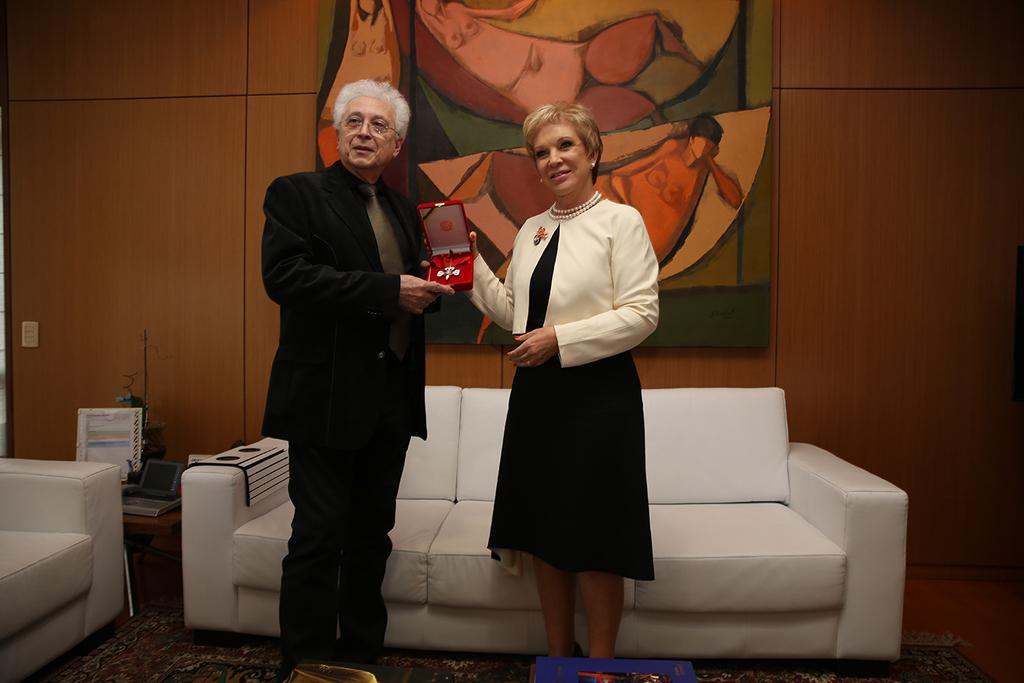How many people are in the image? There is a man and a woman in the image. What are the man and woman doing in the image? The man and woman are standing and holding an ornament. What type of furniture is present in the image? There is a sofa and a chair in the image. What can be seen on the wall in the image? There is a frame on the wall in the image. What type of jewel is hidden inside the box on the chair in the image? There is no box or jewel present in the image; it only features a man, a woman, an ornament, a sofa, a chair, and a frame on the wall. 